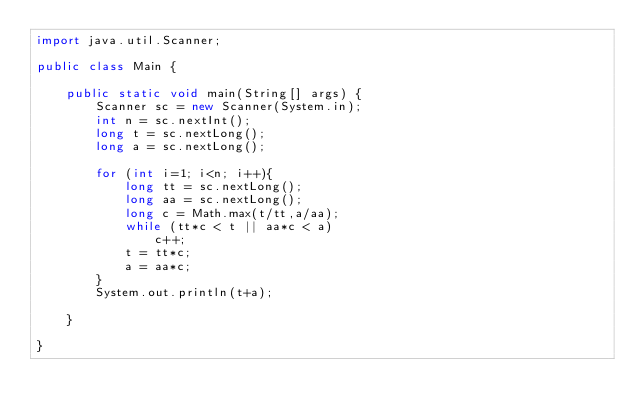<code> <loc_0><loc_0><loc_500><loc_500><_Java_>import java.util.Scanner;

public class Main {

    public static void main(String[] args) {
        Scanner sc = new Scanner(System.in);
        int n = sc.nextInt();
        long t = sc.nextLong();
        long a = sc.nextLong();
        
        for (int i=1; i<n; i++){
            long tt = sc.nextLong();
            long aa = sc.nextLong();
            long c = Math.max(t/tt,a/aa);
            while (tt*c < t || aa*c < a)
                c++;
            t = tt*c;
            a = aa*c;
        }
        System.out.println(t+a);
        
    }

}
</code> 